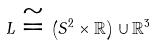Convert formula to latex. <formula><loc_0><loc_0><loc_500><loc_500>L \cong \left ( { S } ^ { 2 } \times \mathbb { R } \right ) \cup \mathbb { R } ^ { 3 }</formula> 